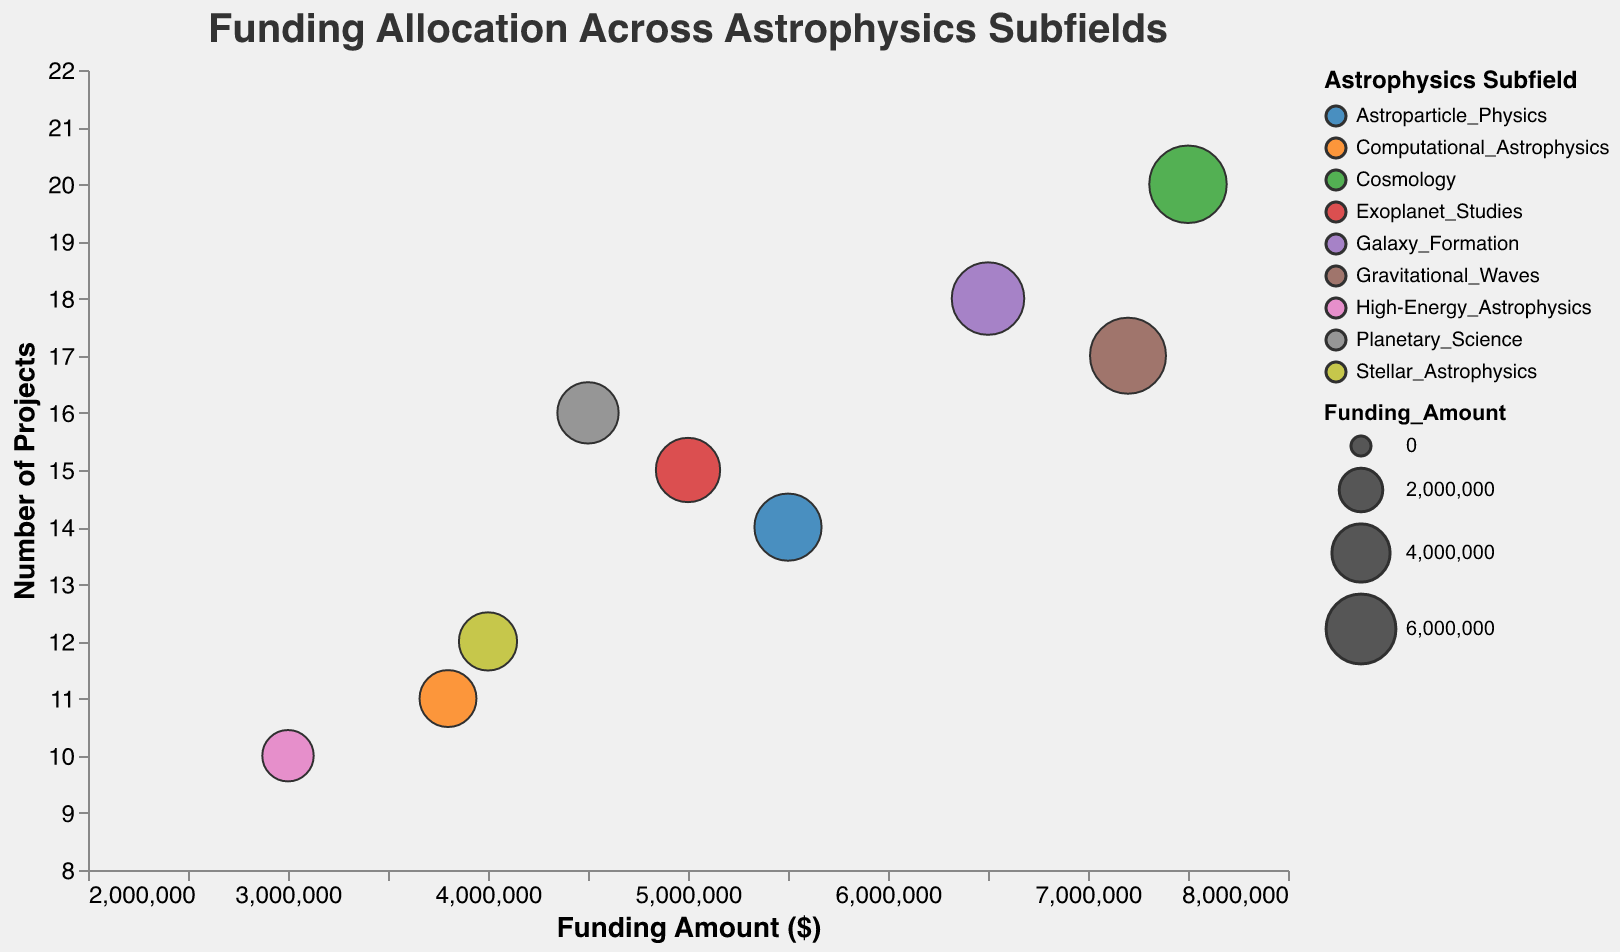What's the title of the bubble chart? The title of the chart is displayed at the top and is visually distinguishable from other elements.
Answer: Funding Allocation Across Astrophysics Subfields Which subfield has the principal investigator George Efstathiou? By looking at the tooltip associated with the bubble representing George Efstathiou, it shows the subfield he is in.
Answer: Cosmology How many projects does the subfield with the largest funding amount have? The largest bubble, indicating the highest funding amount, is associated with Cosmology. Checking the "Number of Projects," it shows 20 projects.
Answer: 20 Which subfield has the smallest bubble? The size of the bubble represents the funding amount. The smallest bubble visually can be identified as "High-Energy Astrophysics," which has a funding amount of $3,000,000.
Answer: High-Energy Astrophysics Compare the funding amounts between "Gravitational Waves" and "Galaxy Formation." Which one is higher, and by how much? The "Gravitational Waves" has $7,200,000, and "Galaxy Formation" has $6,500,000. The difference between them is $7,200,000 - $6,500,000 = $700,000.
Answer: Gravitational Waves by $700,000 Which subfield has the second highest number of projects? By comparing the "Number of Projects," the subfield with the second highest number of projects, after Cosmology (20), is "Galaxy Formation" with 18 projects.
Answer: Galaxy Formation What is the average funding amount across all subfields? Summing up all the funding amounts (5,000,000 + 7,500,000 + 4,000,000 + 6,500,000 + 3,000,000 + 5,500,000 + 7,200,000 + 4,500,000 + 3,800,000) and dividing by the number of subfields (9) gives the average. The sum is $47,000,000. Average = $47,000,000 / 9 ≈ $5,222,222.
Answer: $5,222,222 Identify the principal investigator with the highest number of projects and the corresponding subfield. By comparing the "Number of Projects" values, the highest number, 20, corresponds to George Efstathiou in the Cosmology subfield.
Answer: George Efstathiou, Cosmology 